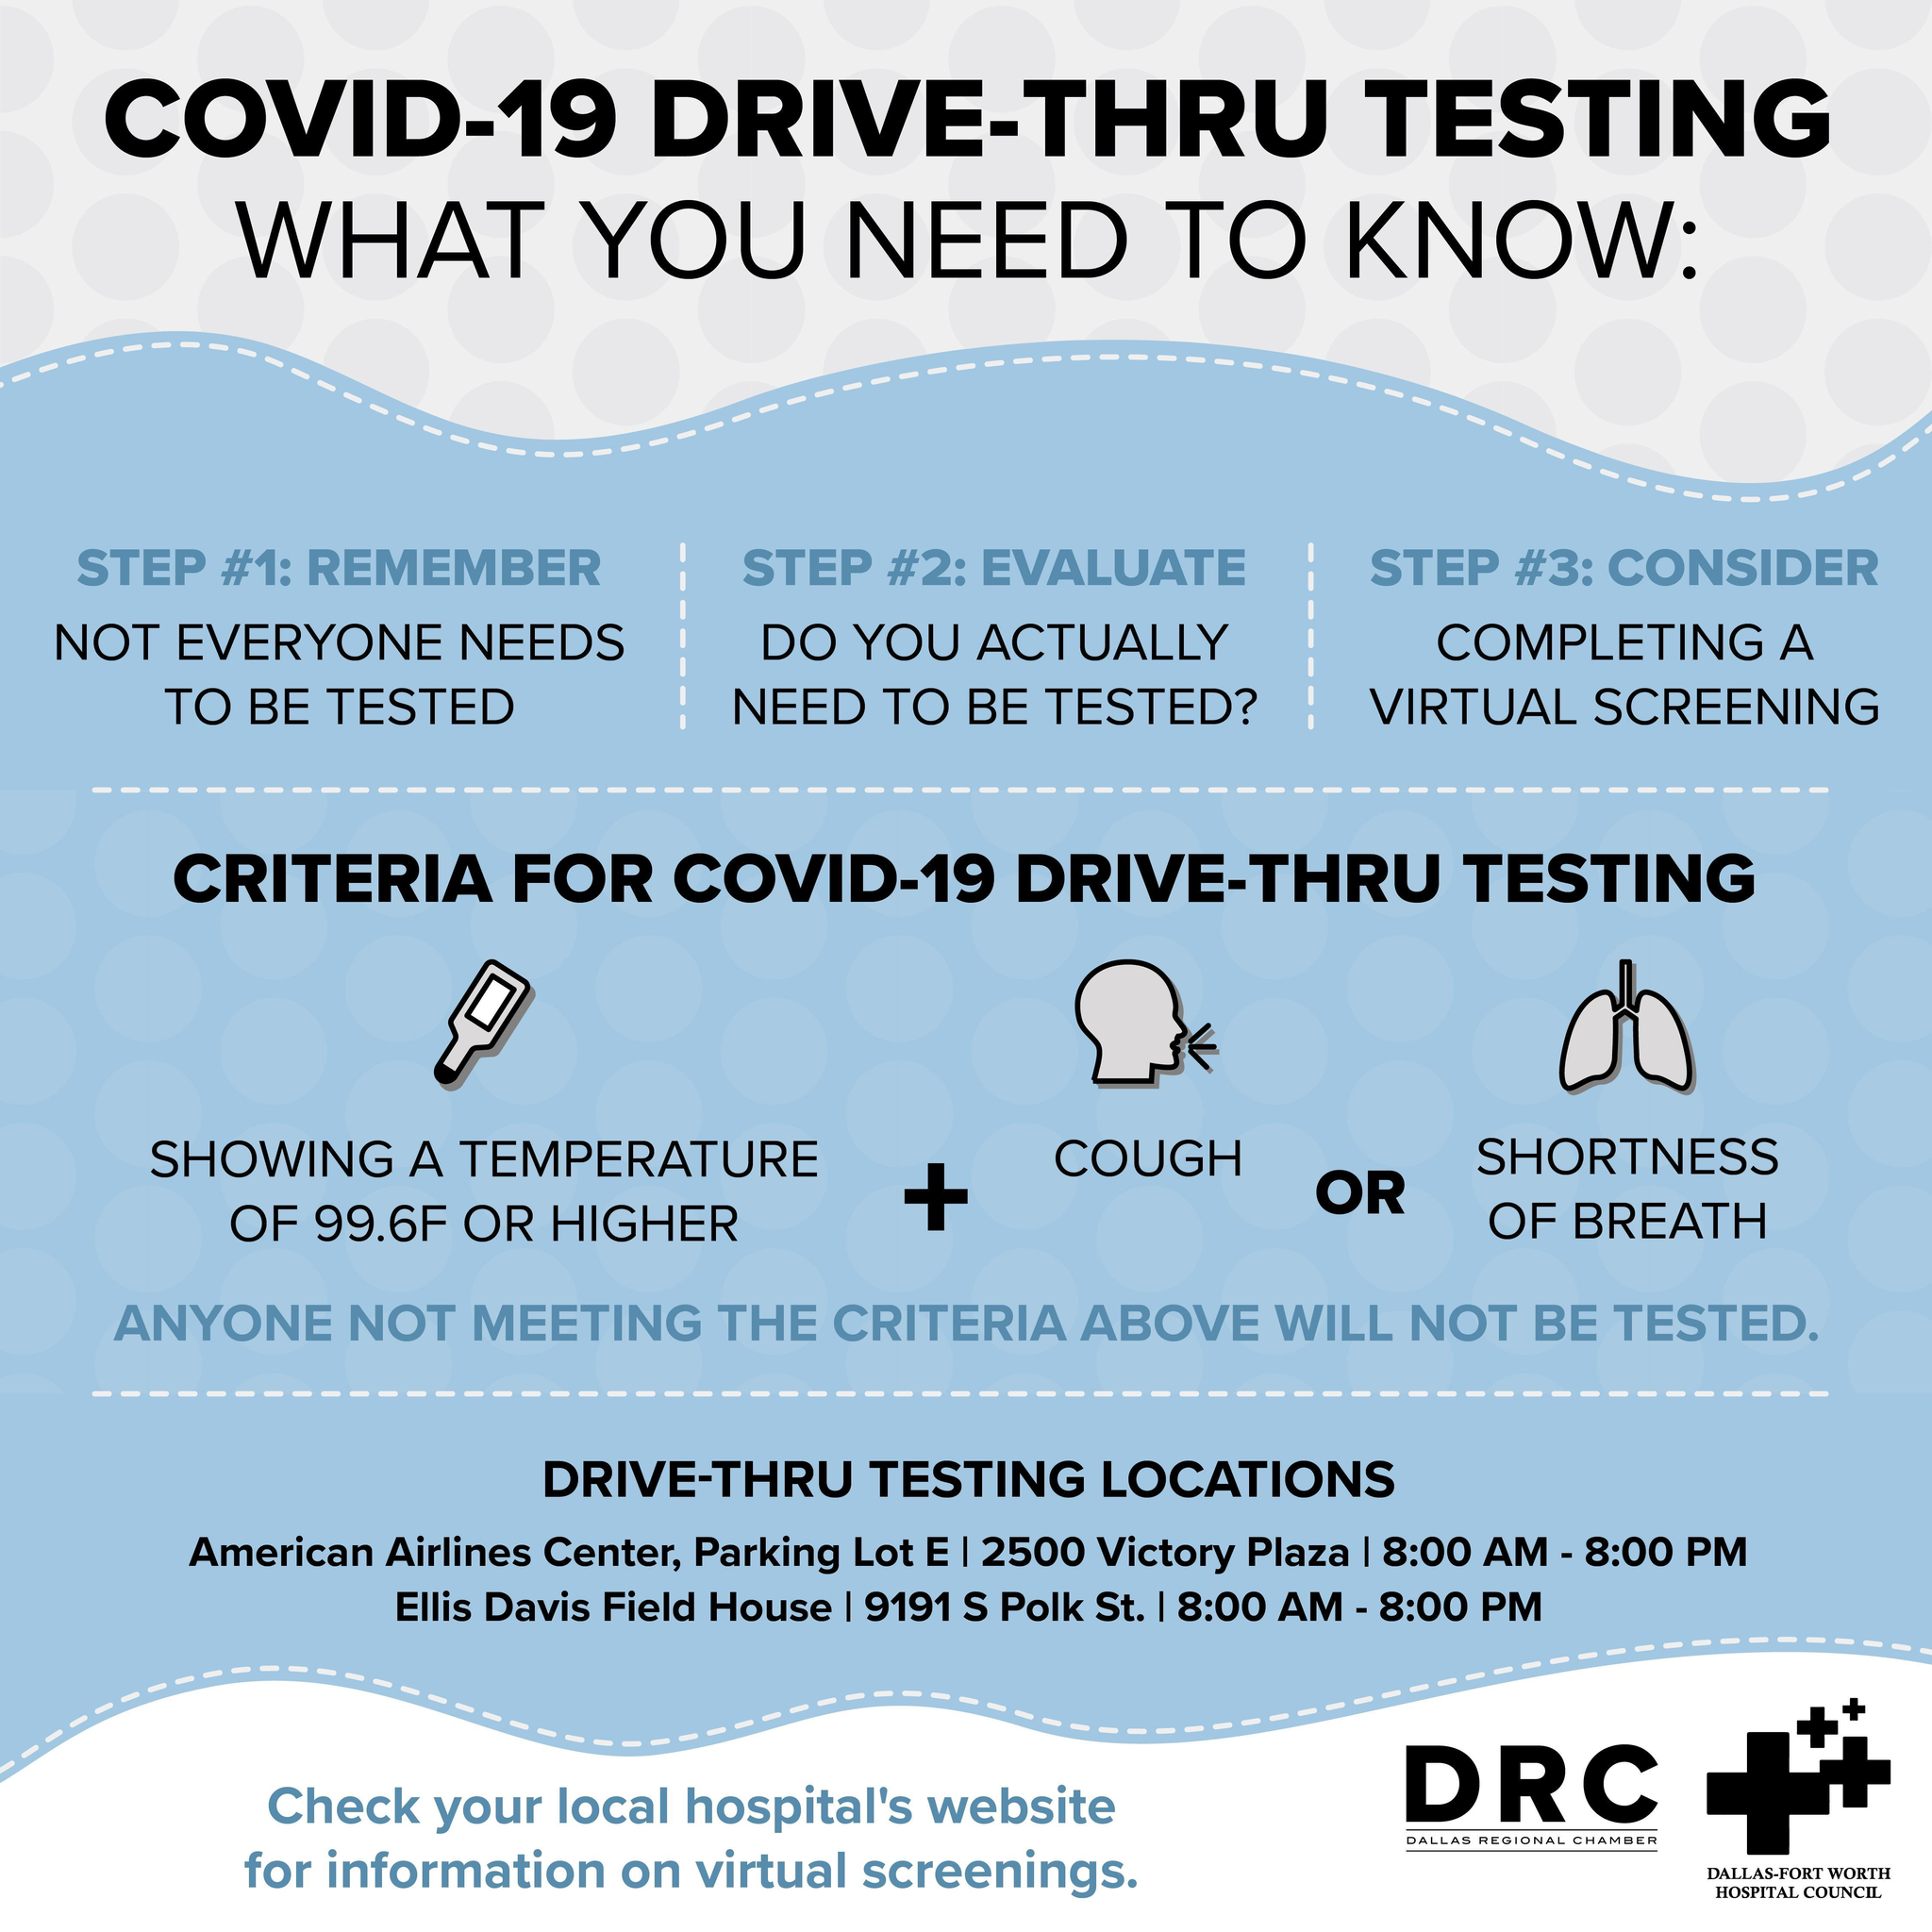How many factors are considered for Covid-19 drive through testing?
Answer the question with a short phrase. 3 What is the first criteria listed for Covid-19 drive through testing? Showing a temperature of 99.6F or higher What is the step 2 of Covid-19 drive-thru testing? Do you actually need to be tested? What are the 3 steps to be completed before undergoing Covid-19 drive-thru testing? Remember, Evaluate, Consider Which are the two criteria given in  OR condition? Cough, Shortness of breath What is the step 3 of Covid-19 drive-thru testing? Completing a virtual screening 